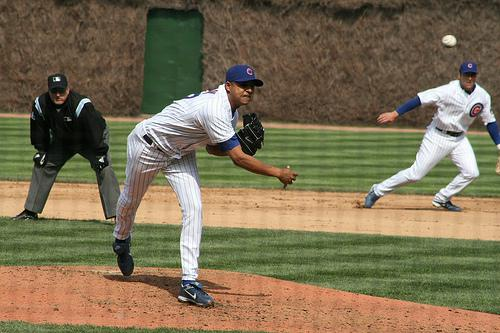Question: who is throwing the ball?
Choices:
A. The player.
B. The lineman.
C. The pitcher.
D. The quarterback.
Answer with the letter. Answer: C Question: what is the pitcher holding?
Choices:
A. A mitt.
B. A ball.
C. A bat.
D. A sign.
Answer with the letter. Answer: A Question: what sport is being played?
Choices:
A. Baseball.
B. Basketball.
C. Tennis.
D. Soccer.
Answer with the letter. Answer: A Question: what color hats do the players in white have?
Choices:
A. Blue.
B. Green.
C. Red.
D. Yellow.
Answer with the letter. Answer: A 